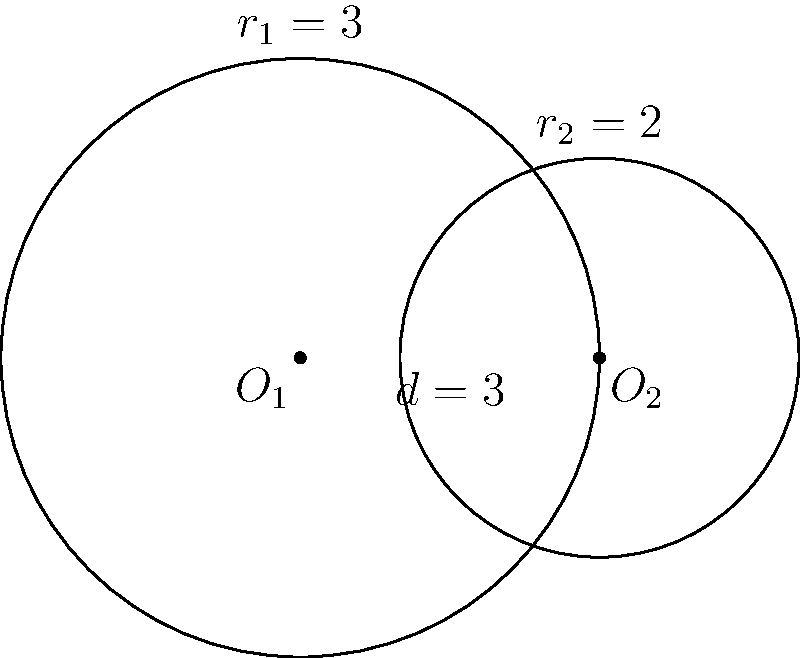Two circles with radii $r_1 = 3$ and $r_2 = 2$ intersect as shown in the figure. The distance between their centers is $d = 3$. Calculate the area of the overlapping region between the two circles. To calculate the area of the overlapping region, we'll use the formula for the area of intersection of two circles:

1) First, calculate the central angles $\theta_1$ and $\theta_2$ using the law of cosines:

   $$\cos(\theta_1/2) = \frac{r_1^2 + d^2 - r_2^2}{2r_1d}$$
   $$\cos(\theta_2/2) = \frac{r_2^2 + d^2 - r_1^2}{2r_2d}$$

2) Substitute the values:
   $$\cos(\theta_1/2) = \frac{3^2 + 3^2 - 2^2}{2 \cdot 3 \cdot 3} = \frac{14}{18}$$
   $$\cos(\theta_2/2) = \frac{2^2 + 3^2 - 3^2}{2 \cdot 2 \cdot 3} = \frac{1}{6}$$

3) Calculate $\theta_1$ and $\theta_2$:
   $$\theta_1 = 2 \arccos(\frac{14}{18}) \approx 1.8545 \text{ radians}$$
   $$\theta_2 = 2 \arccos(\frac{1}{6}) \approx 2.7307 \text{ radians}$$

4) The area of the overlapping region is given by:
   $$A = \frac{1}{2}r_1^2(\theta_1 - \sin\theta_1) + \frac{1}{2}r_2^2(\theta_2 - \sin\theta_2)$$

5) Substitute the values and calculate:
   $$A = \frac{1}{2}3^2(1.8545 - \sin(1.8545)) + \frac{1}{2}2^2(2.7307 - \sin(2.7307))$$
   $$A \approx 3.1838$$

Therefore, the area of the overlapping region is approximately 3.1838 square units.
Answer: 3.1838 square units 